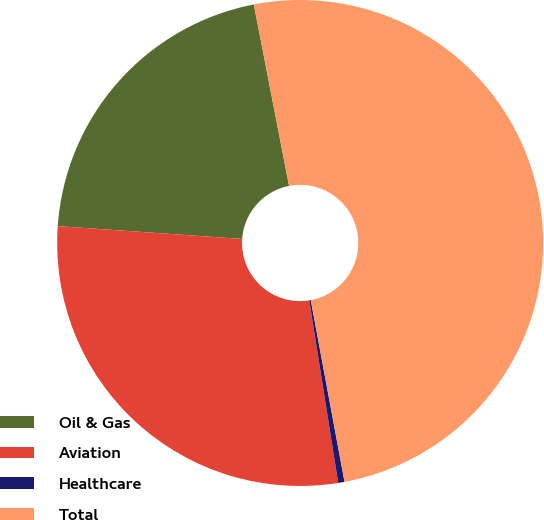Convert chart. <chart><loc_0><loc_0><loc_500><loc_500><pie_chart><fcel>Oil & Gas<fcel>Aviation<fcel>Healthcare<fcel>Total<nl><fcel>20.84%<fcel>28.61%<fcel>0.42%<fcel>50.13%<nl></chart> 